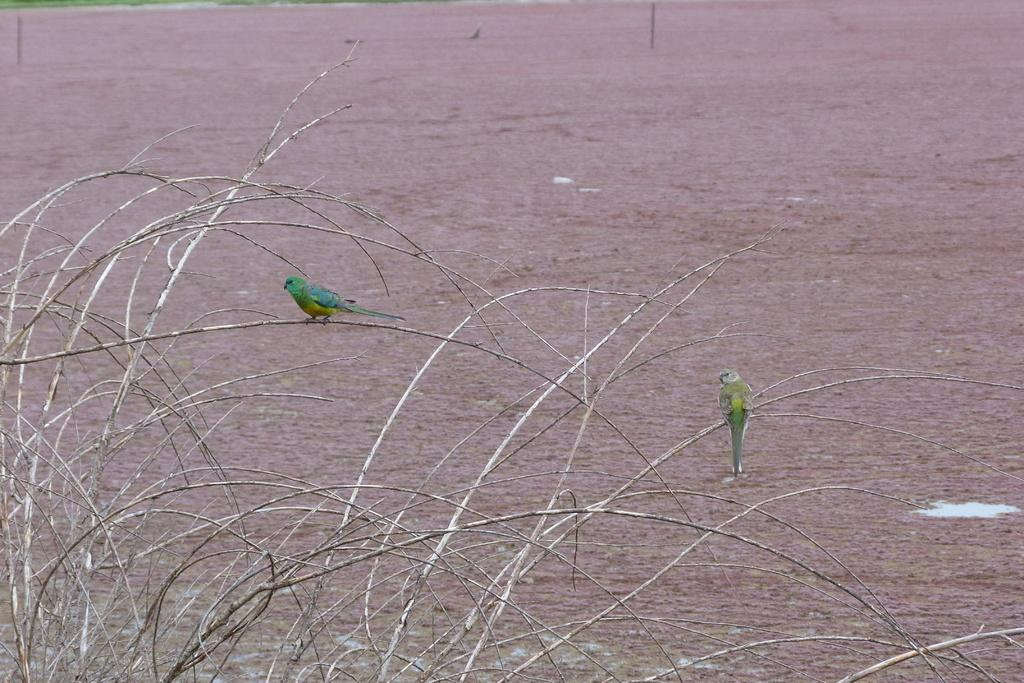What type of animals are in the image? There are two green color birds in the image. Where are the birds located? The birds are on a branch. What can be seen in the background of the image? There is grass and ground visible in the background of the image. What type of weather can be seen in the image? The provided facts do not mention any weather conditions, so it cannot be determined from the image. 